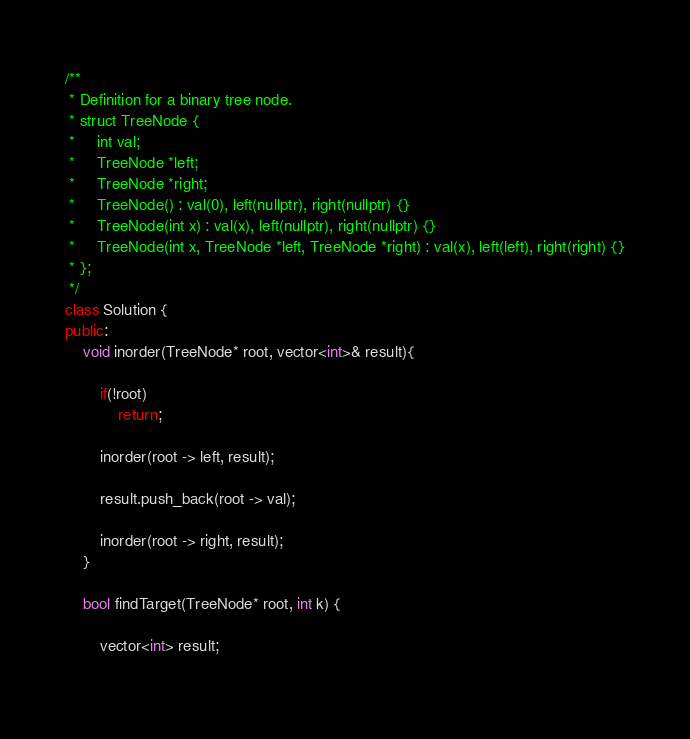Convert code to text. <code><loc_0><loc_0><loc_500><loc_500><_C++_>/**
 * Definition for a binary tree node.
 * struct TreeNode {
 *     int val;
 *     TreeNode *left;
 *     TreeNode *right;
 *     TreeNode() : val(0), left(nullptr), right(nullptr) {}
 *     TreeNode(int x) : val(x), left(nullptr), right(nullptr) {}
 *     TreeNode(int x, TreeNode *left, TreeNode *right) : val(x), left(left), right(right) {}
 * };
 */
class Solution {
public:
    void inorder(TreeNode* root, vector<int>& result){
        
        if(!root)
            return;
        
        inorder(root -> left, result);
        
        result.push_back(root -> val);
        
        inorder(root -> right, result);
    }
    
    bool findTarget(TreeNode* root, int k) {
        
        vector<int> result;
        </code> 